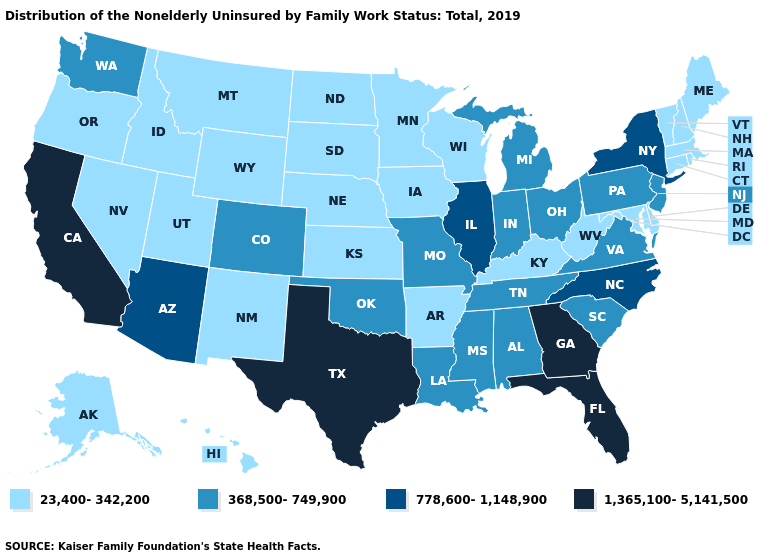What is the value of Colorado?
Answer briefly. 368,500-749,900. Name the states that have a value in the range 368,500-749,900?
Be succinct. Alabama, Colorado, Indiana, Louisiana, Michigan, Mississippi, Missouri, New Jersey, Ohio, Oklahoma, Pennsylvania, South Carolina, Tennessee, Virginia, Washington. Among the states that border Georgia , which have the lowest value?
Be succinct. Alabama, South Carolina, Tennessee. Which states have the lowest value in the USA?
Concise answer only. Alaska, Arkansas, Connecticut, Delaware, Hawaii, Idaho, Iowa, Kansas, Kentucky, Maine, Maryland, Massachusetts, Minnesota, Montana, Nebraska, Nevada, New Hampshire, New Mexico, North Dakota, Oregon, Rhode Island, South Dakota, Utah, Vermont, West Virginia, Wisconsin, Wyoming. Does Iowa have the lowest value in the MidWest?
Be succinct. Yes. What is the lowest value in the South?
Short answer required. 23,400-342,200. What is the value of Nevada?
Quick response, please. 23,400-342,200. Does Utah have the lowest value in the USA?
Keep it brief. Yes. Which states have the lowest value in the USA?
Write a very short answer. Alaska, Arkansas, Connecticut, Delaware, Hawaii, Idaho, Iowa, Kansas, Kentucky, Maine, Maryland, Massachusetts, Minnesota, Montana, Nebraska, Nevada, New Hampshire, New Mexico, North Dakota, Oregon, Rhode Island, South Dakota, Utah, Vermont, West Virginia, Wisconsin, Wyoming. What is the highest value in states that border Kentucky?
Concise answer only. 778,600-1,148,900. Does Indiana have the lowest value in the USA?
Write a very short answer. No. Name the states that have a value in the range 368,500-749,900?
Short answer required. Alabama, Colorado, Indiana, Louisiana, Michigan, Mississippi, Missouri, New Jersey, Ohio, Oklahoma, Pennsylvania, South Carolina, Tennessee, Virginia, Washington. Does the first symbol in the legend represent the smallest category?
Concise answer only. Yes. Does California have the highest value in the West?
Quick response, please. Yes. How many symbols are there in the legend?
Answer briefly. 4. 